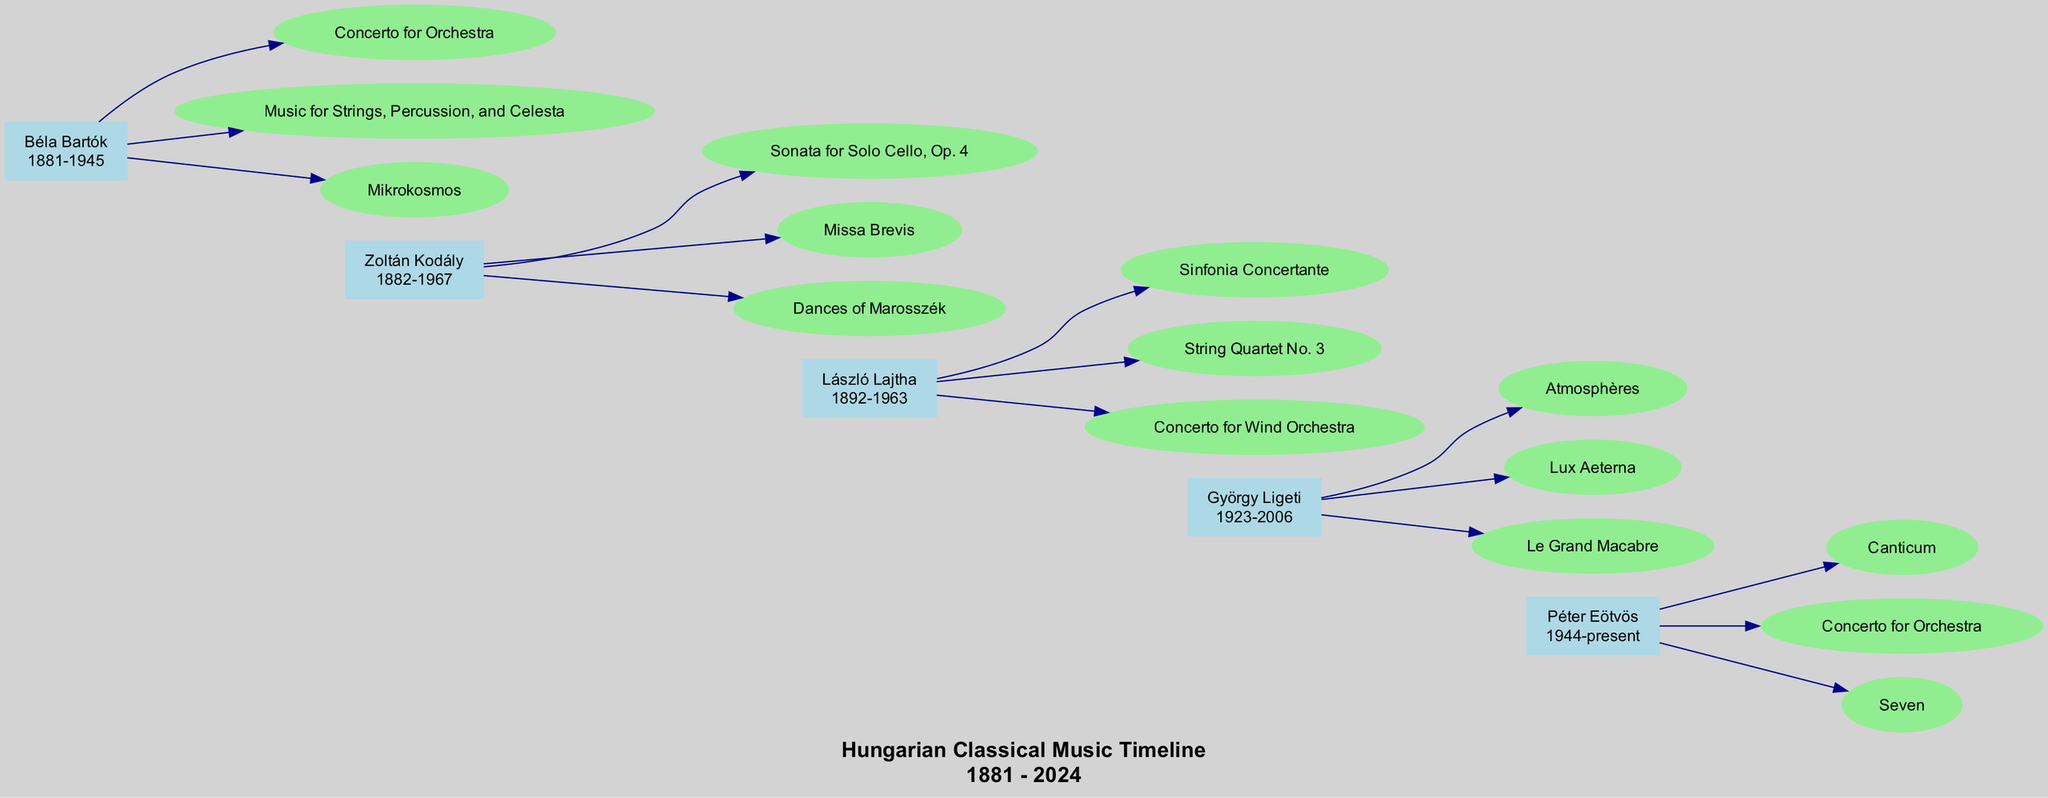What is the birth year of Zoltán Kodály? Zoltán Kodály's period is listed as 1882-1967, so the birth year is the first part of this range: 1882.
Answer: 1882 Which work is attributed to Béla Bartók? The works listed under Béla Bartók include "Concerto for Orchestra," "Music for Strings, Percussion, and Celesta," and "Mikrokosmos." Any of these would be correct, but we can directly refer to the first as an example.
Answer: Concerto for Orchestra How many works are associated with György Ligeti? György Ligeti has three works listed: "Atmosphères," "Lux Aeterna," and "Le Grand Macabre." To find the answer, we simply count these entries.
Answer: 3 Which composer has works that include "Sinfonia Concertante"? "Sinfonia Concertante" is found under László Lajtha's works. By checking the works associated with each composer, we can identify its correct attribution.
Answer: László Lajtha What is the total number of composers represented in the diagram? There are five composers listed: Zoltán Kodály, Béla Bartók, György Ligeti, László Lajtha, and Péter Eötvös. Each one can be counted directly from the diagram.
Answer: 5 Who is the first composer chronologically in the diagram? By examining the birth years of the composers, we identify Zoltán Kodály as he was born in 1882, making him the first in chronological order.
Answer: Zoltán Kodály What sort of connection exists between Béla Bartók and György Ligeti in the diagram? In the diagram, Béla Bartók and György Ligeti are connected by an invisible edge, representing a chronological relationship where Ligeti follows Bartók.
Answer: Invisible connection What style are the edges that connect the composers? The edges that connect the composers are styled as invisible, which suggests that they do not visibly connect the composers but still indicate their chronological sequence.
Answer: Invisible How many works does Péter Eötvös have in the diagram? Péter Eötvös is associated with three works: "Canticum," "Concerto for Orchestra," and "Seven." By counting the entries, we can determine the total.
Answer: 3 